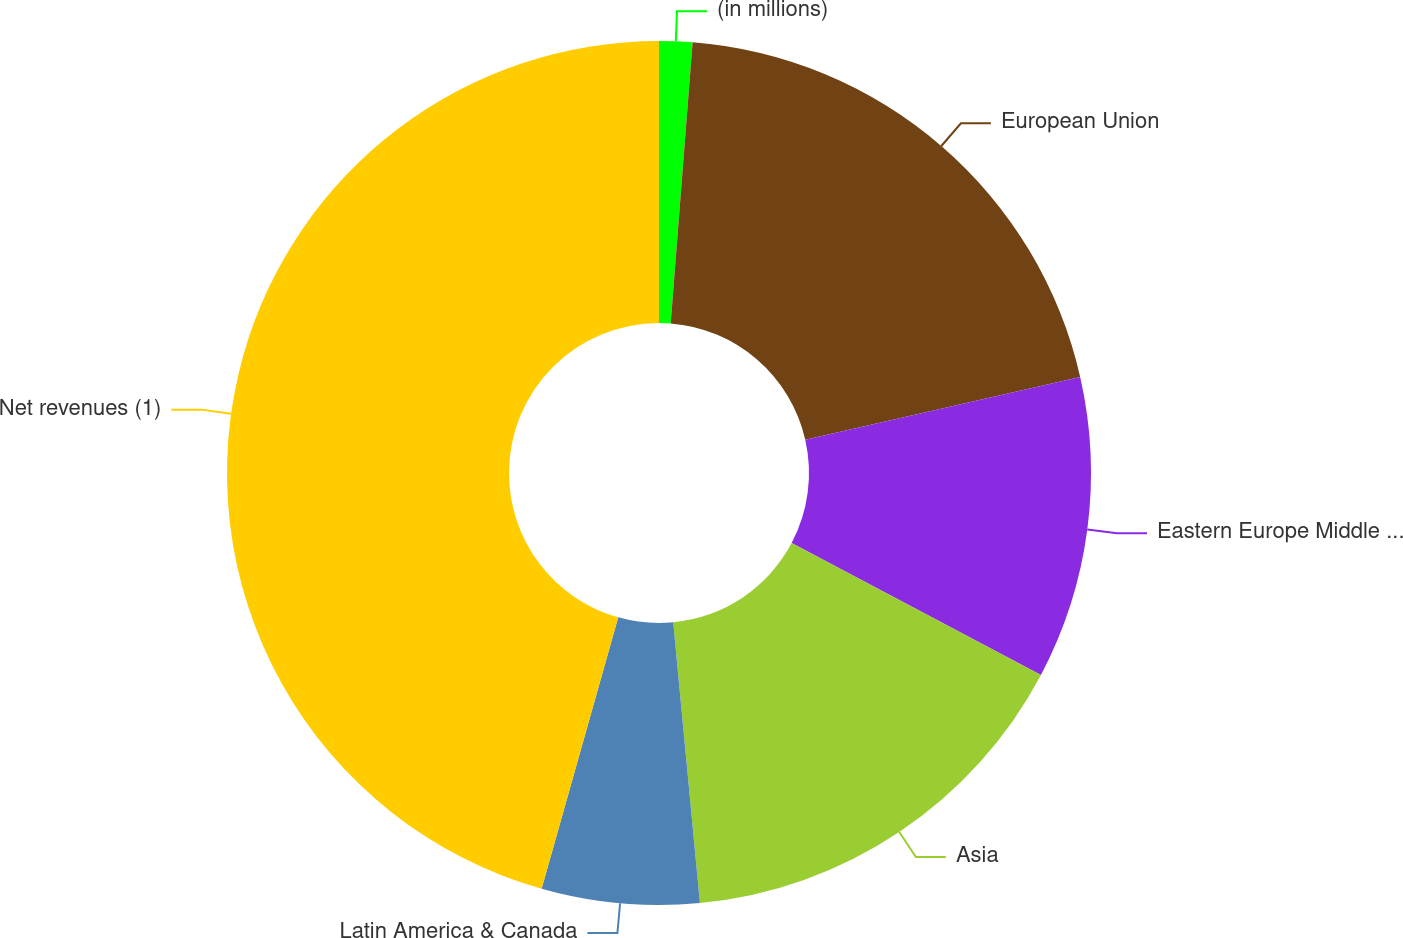Convert chart. <chart><loc_0><loc_0><loc_500><loc_500><pie_chart><fcel>(in millions)<fcel>European Union<fcel>Eastern Europe Middle East &<fcel>Asia<fcel>Latin America & Canada<fcel>Net revenues (1)<nl><fcel>1.24%<fcel>20.19%<fcel>11.31%<fcel>15.75%<fcel>5.89%<fcel>45.62%<nl></chart> 